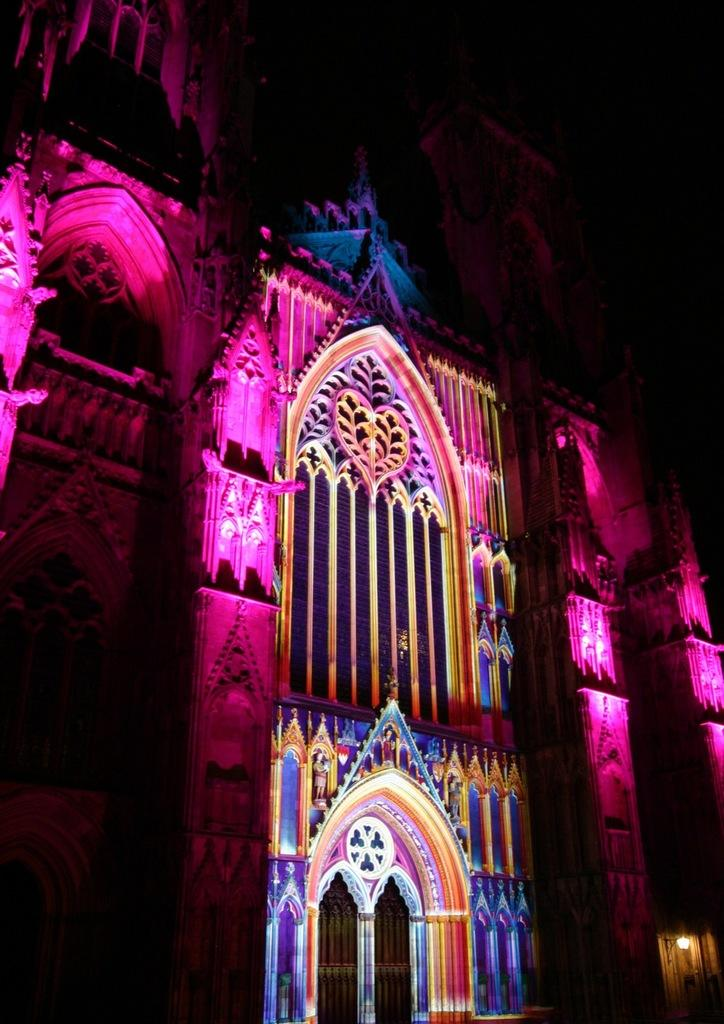What is the lighting condition in the image? The image was clicked in the dark. What structure can be seen in the image? There is a building visible in the image. What type of food is being prepared in the image? There is no food preparation visible in the image; it only features a building in the dark. What type of flight is taking place in the image? There is no flight visible in the image; it only features a building in the dark. 